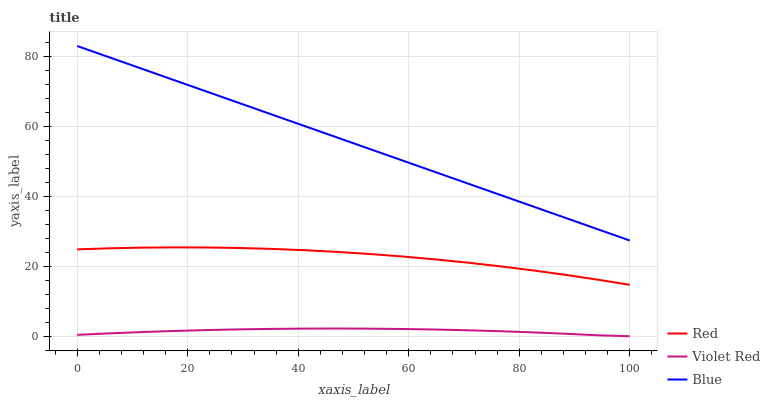Does Violet Red have the minimum area under the curve?
Answer yes or no. Yes. Does Blue have the maximum area under the curve?
Answer yes or no. Yes. Does Red have the minimum area under the curve?
Answer yes or no. No. Does Red have the maximum area under the curve?
Answer yes or no. No. Is Blue the smoothest?
Answer yes or no. Yes. Is Red the roughest?
Answer yes or no. Yes. Is Violet Red the smoothest?
Answer yes or no. No. Is Violet Red the roughest?
Answer yes or no. No. Does Violet Red have the lowest value?
Answer yes or no. Yes. Does Red have the lowest value?
Answer yes or no. No. Does Blue have the highest value?
Answer yes or no. Yes. Does Red have the highest value?
Answer yes or no. No. Is Red less than Blue?
Answer yes or no. Yes. Is Blue greater than Violet Red?
Answer yes or no. Yes. Does Red intersect Blue?
Answer yes or no. No. 